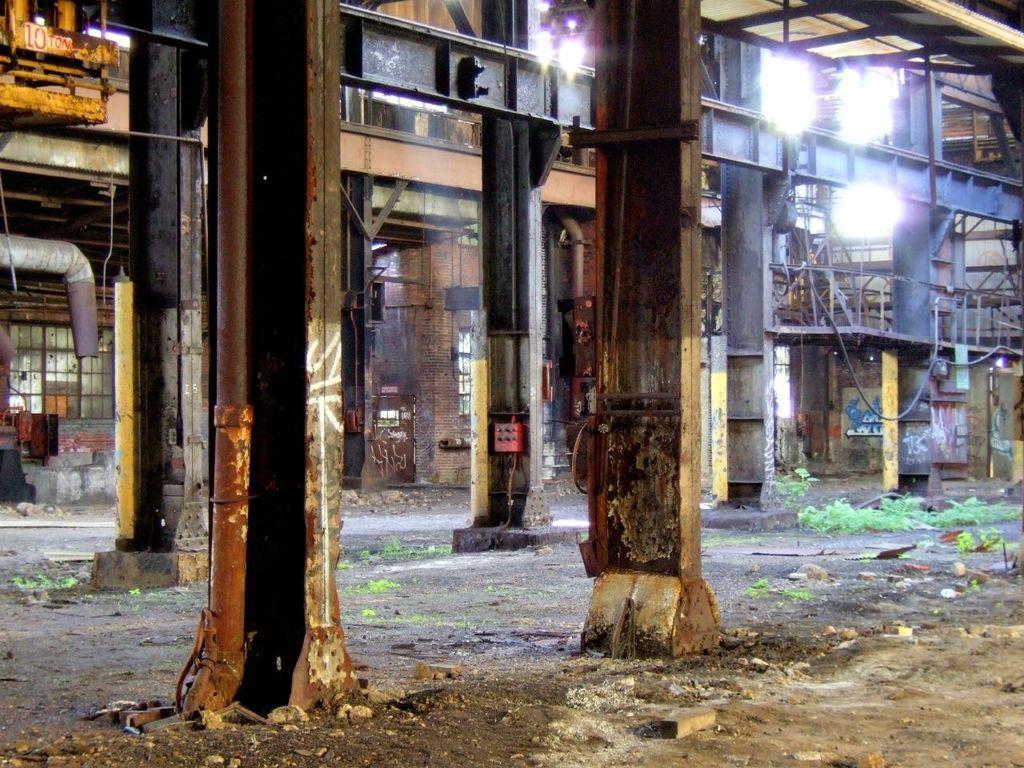Can you describe this image briefly? In this image, we can see few pillars, brick walls, pipes, rods, lights, glass windows. At the bottom of the image, we can see ground, few stones, plants. In the middle of the image, we can see some red color box here. 